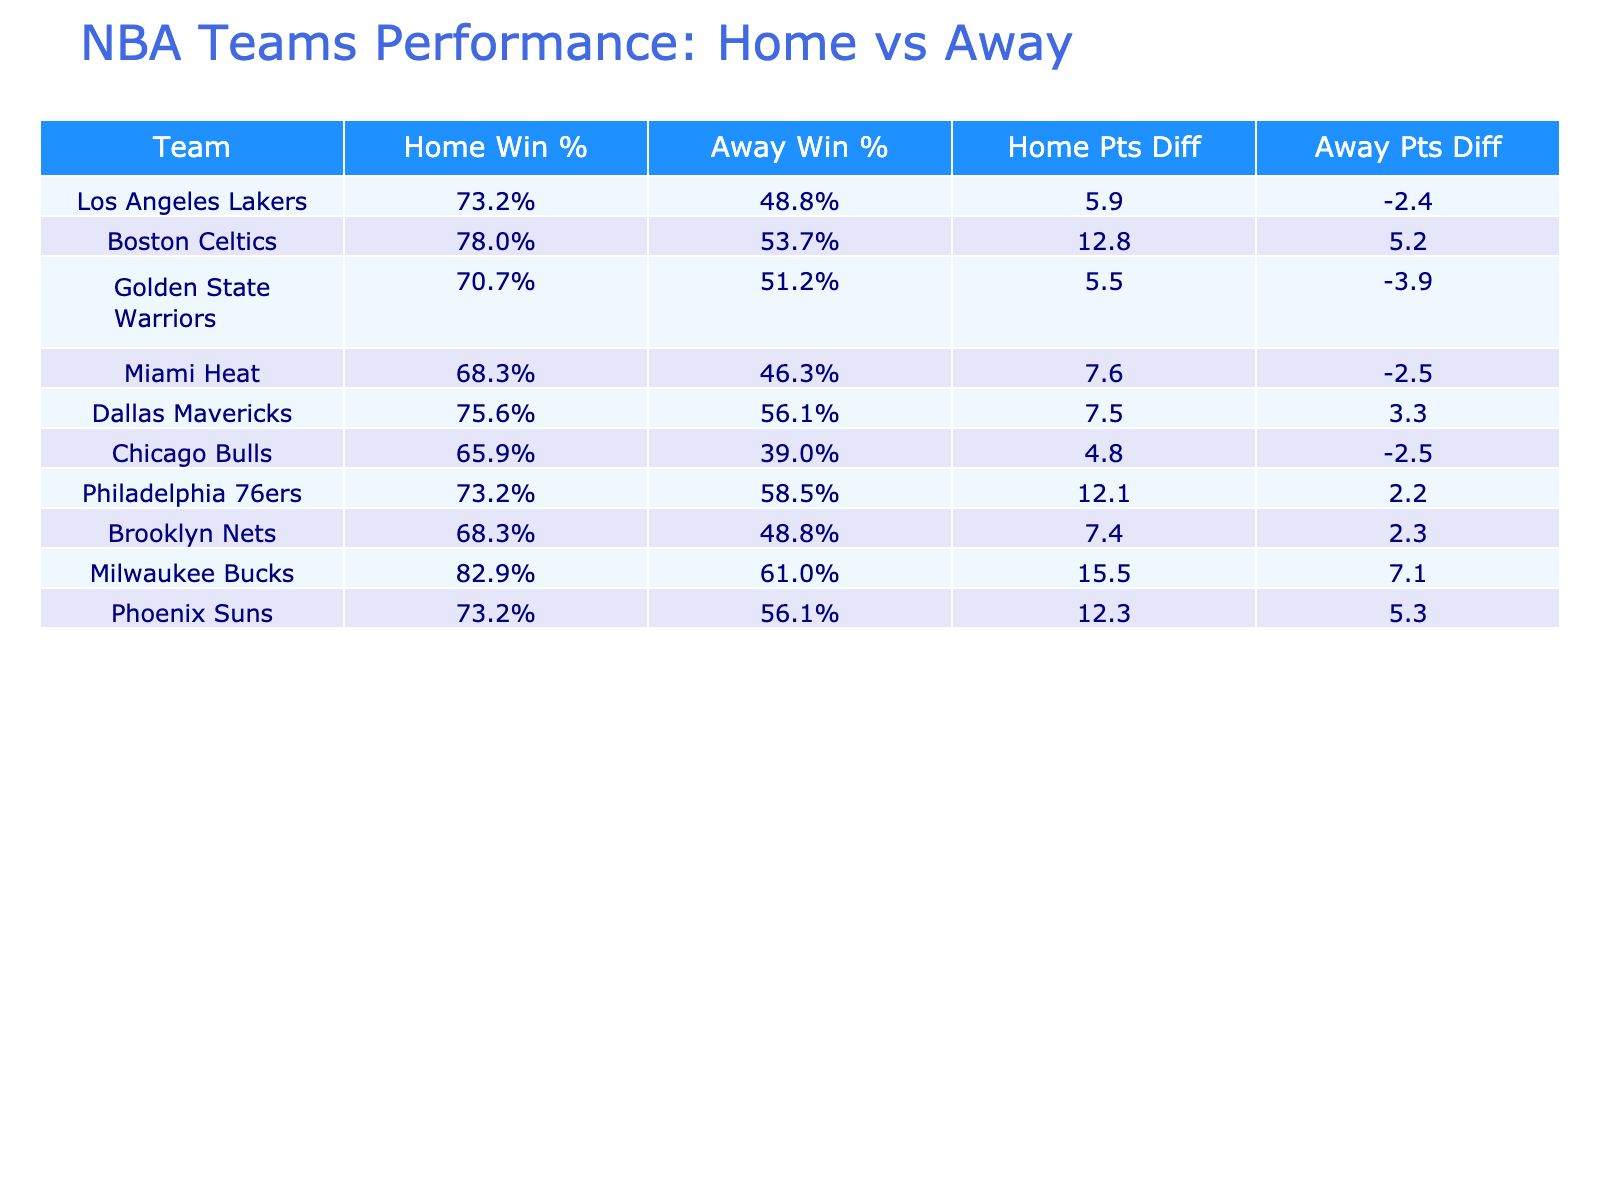What is the home win percentage for the Boston Celtics? The home win percentage for the Boston Celtics is calculated by dividing their home wins (32) by the number of home games (41). This gives a result of 32/41 = 0.7805, which translates to 78.1%
Answer: 78.1% Which team has the highest points differential at home? To find the highest points differential at home, we look at the "Home Points Diff" column. The Milwaukee Bucks have the highest points differential at home with 15.5 points (118.0 - 102.5).
Answer: Milwaukee Bucks Is it true that the Miami Heat won more games at home than away? Checking the wins: Miami Heat won 28 games at home and 19 away. Since 28 is greater than 19, the statement is true
Answer: Yes Calculate the average away win percentage for all teams listed. To find the average away win percentage, we first sum the away win percentages of all teams: (20/41 + 22/41 + 21/41 + 19/41 + 23/41 + 16/41 + 24/41 + 20/41 + 25/41) = 0.5378. Dividing by the number of teams (9), gives a result of 0.5378, approximately 53.8%.
Answer: 53.8% Does the Golden State Warriors have a better home win percentage than the Los Angeles Lakers? Comparing their home win percentages: Golden State Warriors have 29/41 ≈ 70.7%, and the Los Angeles Lakers have 30/41 ≈ 73.2%. Since 70.7% is less than 73.2%, Warrior's home win percentage is not better.
Answer: No Which team's games at home have yielded the highest average points scored? To find this, we need to look for the highest points scored in the "Points For Home" column. The Boston Celtics scored an average of 118.4 points at home, which is the highest among all teams listed
Answer: Boston Celtics 